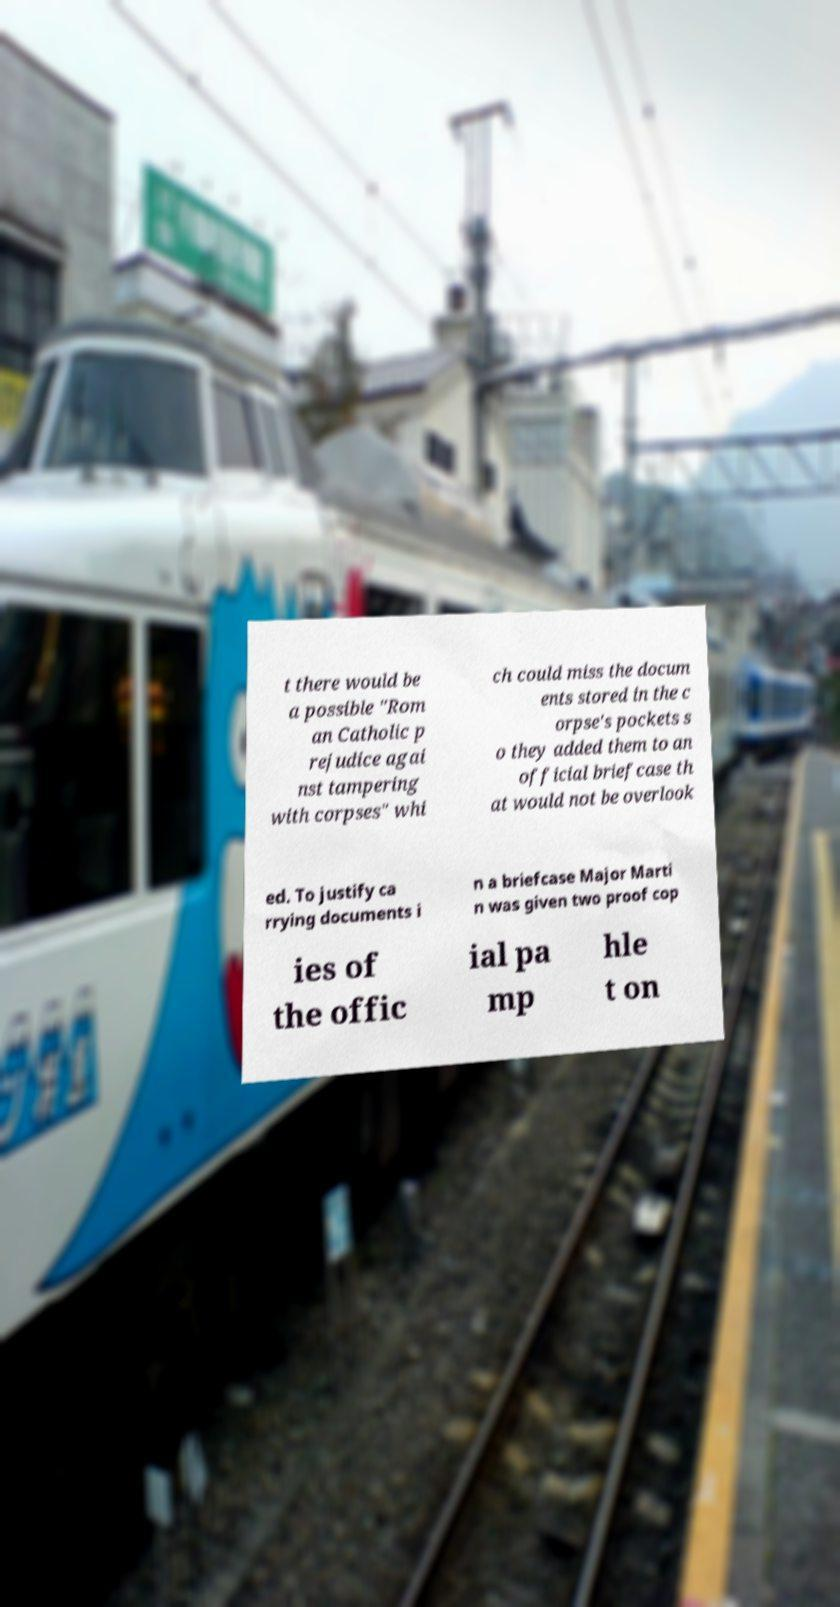Could you extract and type out the text from this image? t there would be a possible "Rom an Catholic p rejudice agai nst tampering with corpses" whi ch could miss the docum ents stored in the c orpse's pockets s o they added them to an official briefcase th at would not be overlook ed. To justify ca rrying documents i n a briefcase Major Marti n was given two proof cop ies of the offic ial pa mp hle t on 